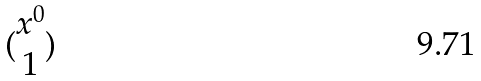Convert formula to latex. <formula><loc_0><loc_0><loc_500><loc_500>( \begin{matrix} x ^ { 0 } \\ 1 \end{matrix} )</formula> 